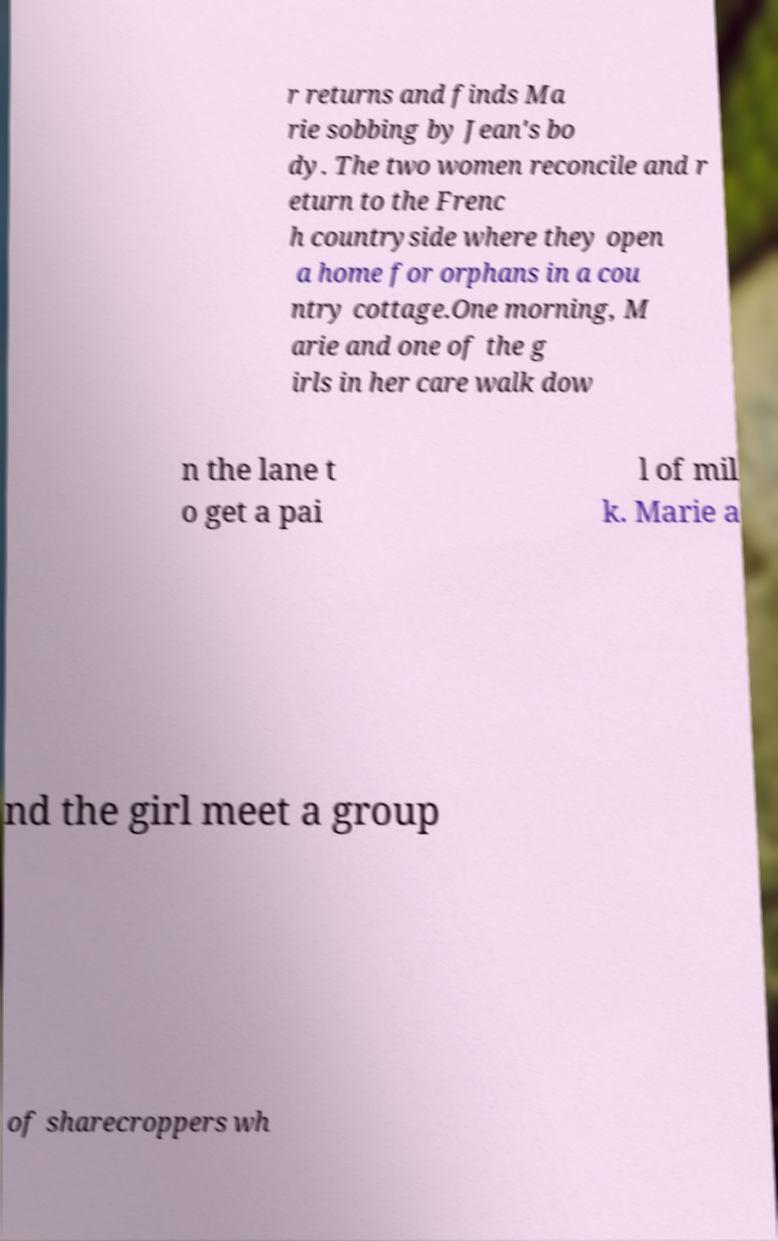Please identify and transcribe the text found in this image. r returns and finds Ma rie sobbing by Jean's bo dy. The two women reconcile and r eturn to the Frenc h countryside where they open a home for orphans in a cou ntry cottage.One morning, M arie and one of the g irls in her care walk dow n the lane t o get a pai l of mil k. Marie a nd the girl meet a group of sharecroppers wh 